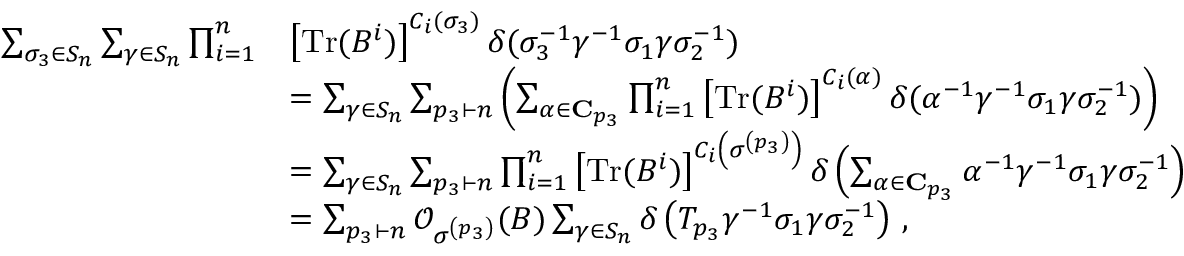<formula> <loc_0><loc_0><loc_500><loc_500>\begin{array} { r l } { \sum _ { \sigma _ { 3 } \in S _ { n } } \sum _ { \gamma \in S _ { n } } \prod _ { i = 1 } ^ { n } } & { \left [ T r ( B ^ { i } ) \right ] ^ { C _ { i } ( \sigma _ { 3 } ) } \delta ( \sigma _ { 3 } ^ { - 1 } \gamma ^ { - 1 } \sigma _ { 1 } \gamma \sigma _ { 2 } ^ { - 1 } ) } \\ & { = \sum _ { \gamma \in S _ { n } } \sum _ { p _ { 3 } \vdash n } \left ( \sum _ { \alpha \in C _ { p _ { 3 } } } \prod _ { i = 1 } ^ { n } \left [ T r ( B ^ { i } ) \right ] ^ { C _ { i } ( \alpha ) } \delta ( \alpha ^ { - 1 } \gamma ^ { - 1 } \sigma _ { 1 } \gamma \sigma _ { 2 } ^ { - 1 } ) \right ) } \\ & { = \sum _ { \gamma \in S _ { n } } \sum _ { p _ { 3 } \vdash n } \prod _ { i = 1 } ^ { n } \left [ T r ( B ^ { i } ) \right ] ^ { C _ { i } \left ( \sigma ^ { \left ( p _ { 3 } \right ) } \right ) } \delta \left ( \sum _ { \alpha \in C _ { p _ { 3 } } } \alpha ^ { - 1 } \gamma ^ { - 1 } \sigma _ { 1 } \gamma \sigma _ { 2 } ^ { - 1 } \right ) } \\ & { = \sum _ { p _ { 3 } \vdash n } \mathcal { O } _ { \sigma ^ { \left ( p _ { 3 } \right ) } } ( B ) \sum _ { \gamma \in S _ { n } } \delta \left ( T _ { p _ { 3 } } \gamma ^ { - 1 } \sigma _ { 1 } \gamma \sigma _ { 2 } ^ { - 1 } \right ) \, , } \end{array}</formula> 